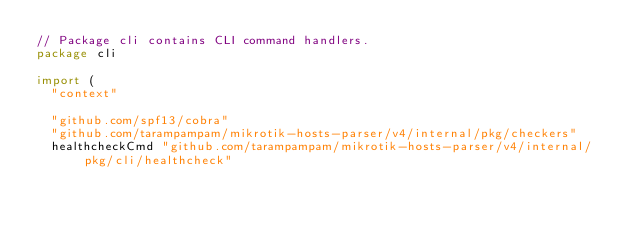Convert code to text. <code><loc_0><loc_0><loc_500><loc_500><_Go_>// Package cli contains CLI command handlers.
package cli

import (
	"context"

	"github.com/spf13/cobra"
	"github.com/tarampampam/mikrotik-hosts-parser/v4/internal/pkg/checkers"
	healthcheckCmd "github.com/tarampampam/mikrotik-hosts-parser/v4/internal/pkg/cli/healthcheck"</code> 